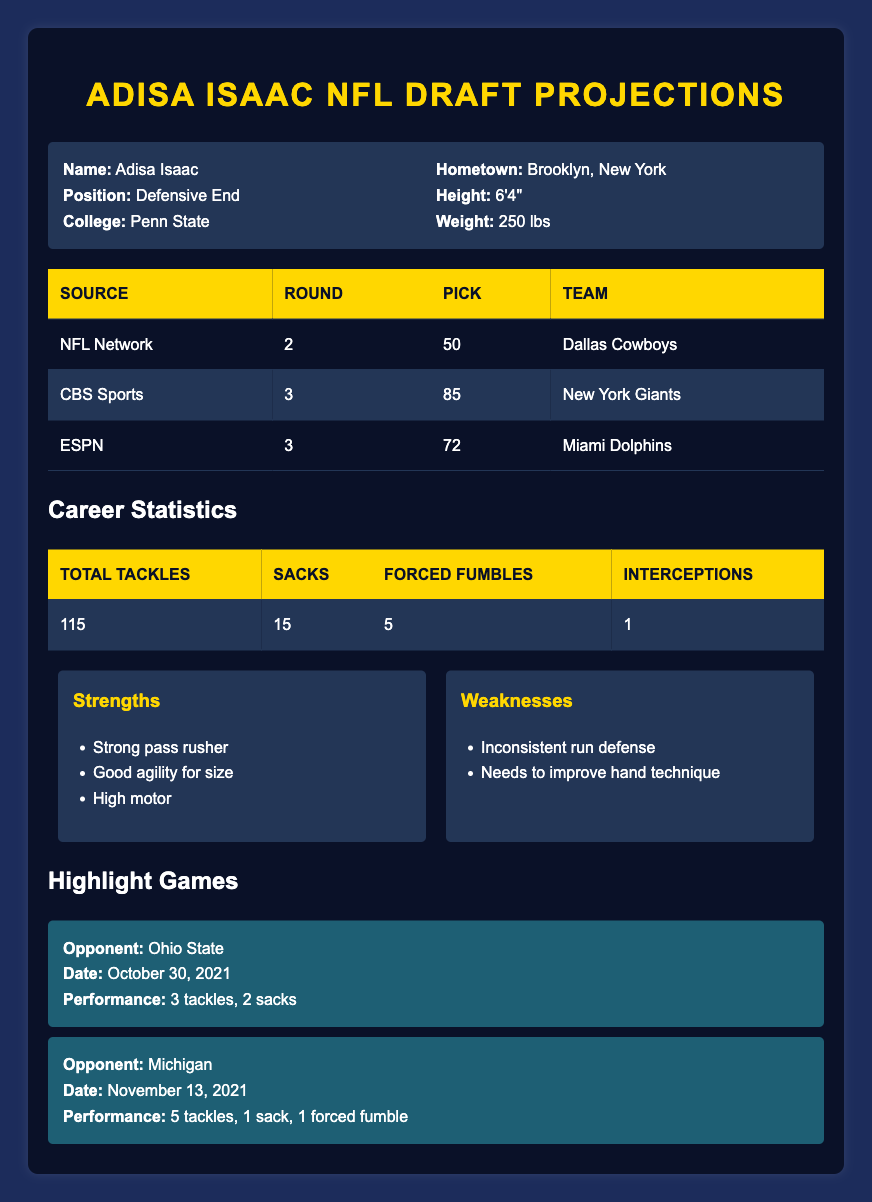What round is Adisa Isaac projected to be drafted in according to NFL Network? From the draft projections table, under the source "NFL Network," the round listed is "2."
Answer: 2 Which team is projected to draft Adisa Isaac with the 85th pick according to CBS Sports? Referring to the draft projections, CBS Sports has him projected to the "New York Giants" with the "85" pick.
Answer: New York Giants How many total tackles has Adisa Isaac recorded in his career? Looking at the career statistics, the total tackles recorded is "115."
Answer: 115 Which team is listed as the 50th pick in the NFL Network projections for Adisa Isaac? From the draft projections provided, for the 50th pick, the team listed is the "Dallas Cowboys."
Answer: Dallas Cowboys What is the average number of sacks and forced fumbles combined in Adisa Isaac's career statistics? The total number of sacks is "15," and the total forced fumbles is "5." Summing these gives 15 + 5 = 20. Therefore, the average for these two statistics is 20/2 = 10.
Answer: 10 Does Adisa Isaac have more sacks than forced fumbles in his career? The number of sacks is "15," and the number of forced fumbles is "5." Since 15 is greater than 5, the answer is yes.
Answer: Yes What were Adisa Isaac's performance stats against Michigan in his highlight games? In the highlight game against Michigan on November 13, 2021, he recorded "5 tackles, 1 sack, and 1 forced fumble."
Answer: 5 tackles, 1 sack, 1 forced fumble Which draft projection source indicates that Adisa Isaac will be picked by the Miami Dolphins? Checking the draft projections, ESPN indicates the Miami Dolphins for the "72" pick.
Answer: ESPN What would be the total number of tackles, sacks, forced fumbles, and interceptions compiled in Adisa Isaac’s career statistics? The total tackles are "115," sacks "15," forced fumbles "5," and interceptions "1." Adding these together gives 115 + 15 + 5 + 1 = 136.
Answer: 136 